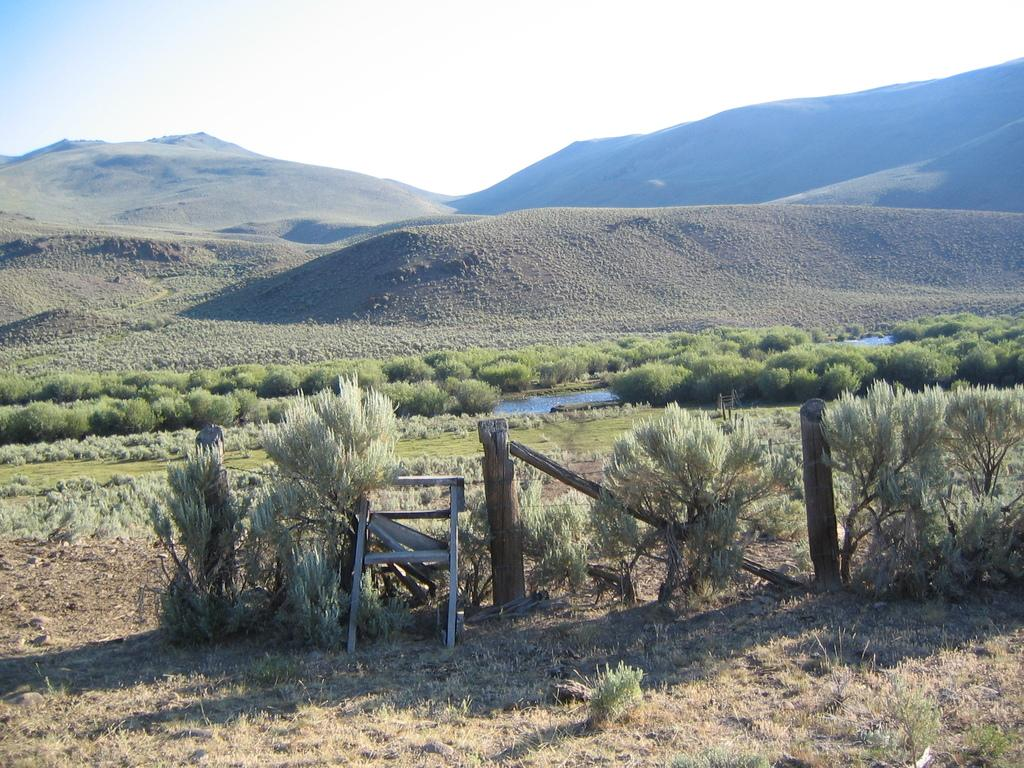What type of vegetation can be seen in the image? There are plants and grass visible in the image. What object is present in the image? There is an object in the image, but its specific nature is not mentioned in the facts. What type of barrier is present in the image? There is a wooden fence in the image. What can be seen in the background of the image? In the background of the image, there are plants, water, hills, and the sky. How many kittens are playing basketball in the image? There are no kittens or basketballs present in the image. What is the belief system of the plants in the image? Plants do not have belief systems, as they are not sentient beings. 